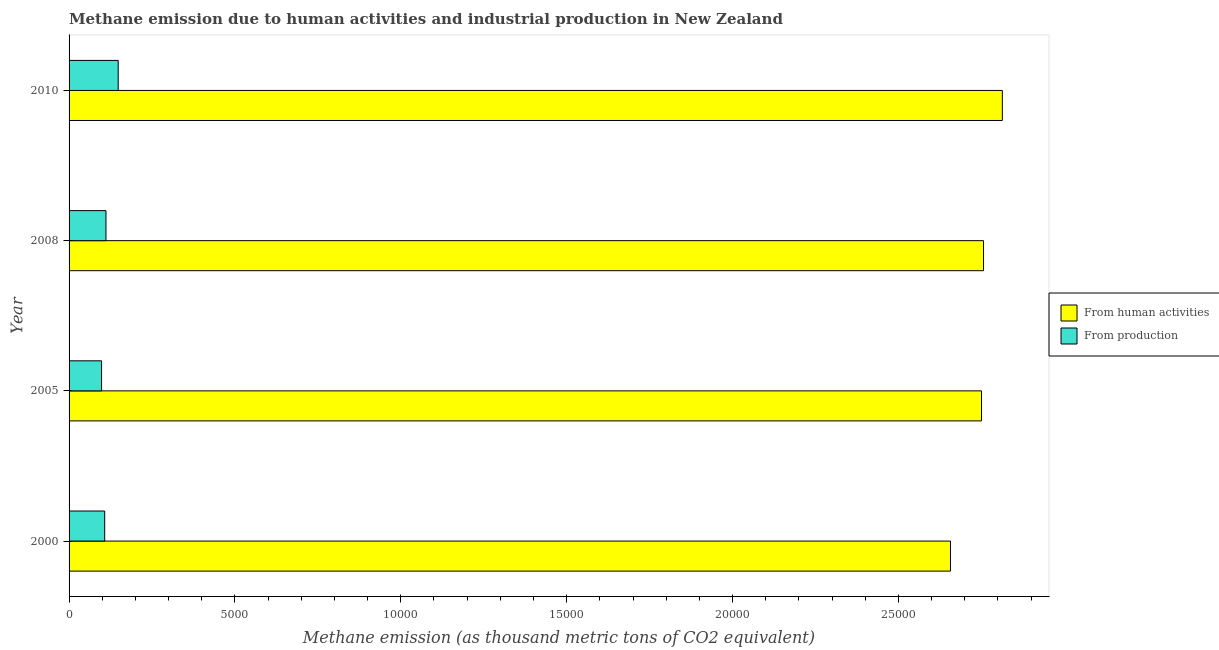How many different coloured bars are there?
Make the answer very short. 2. Are the number of bars per tick equal to the number of legend labels?
Offer a very short reply. Yes. Are the number of bars on each tick of the Y-axis equal?
Ensure brevity in your answer.  Yes. How many bars are there on the 4th tick from the bottom?
Keep it short and to the point. 2. What is the amount of emissions generated from industries in 2008?
Keep it short and to the point. 1112.6. Across all years, what is the maximum amount of emissions from human activities?
Make the answer very short. 2.81e+04. Across all years, what is the minimum amount of emissions from human activities?
Offer a very short reply. 2.66e+04. In which year was the amount of emissions generated from industries maximum?
Provide a short and direct response. 2010. In which year was the amount of emissions generated from industries minimum?
Provide a short and direct response. 2005. What is the total amount of emissions from human activities in the graph?
Give a very brief answer. 1.10e+05. What is the difference between the amount of emissions generated from industries in 2005 and that in 2008?
Give a very brief answer. -133.2. What is the difference between the amount of emissions generated from industries in 2005 and the amount of emissions from human activities in 2008?
Give a very brief answer. -2.66e+04. What is the average amount of emissions from human activities per year?
Keep it short and to the point. 2.74e+04. In the year 2005, what is the difference between the amount of emissions from human activities and amount of emissions generated from industries?
Provide a short and direct response. 2.65e+04. In how many years, is the amount of emissions generated from industries greater than 11000 thousand metric tons?
Your response must be concise. 0. What is the ratio of the amount of emissions from human activities in 2005 to that in 2010?
Ensure brevity in your answer.  0.98. Is the amount of emissions from human activities in 2000 less than that in 2008?
Your response must be concise. Yes. Is the difference between the amount of emissions from human activities in 2005 and 2010 greater than the difference between the amount of emissions generated from industries in 2005 and 2010?
Keep it short and to the point. No. What is the difference between the highest and the second highest amount of emissions generated from industries?
Offer a terse response. 368.6. What is the difference between the highest and the lowest amount of emissions generated from industries?
Your response must be concise. 501.8. What does the 2nd bar from the top in 2000 represents?
Make the answer very short. From human activities. What does the 1st bar from the bottom in 2000 represents?
Your answer should be very brief. From human activities. How many bars are there?
Make the answer very short. 8. How many years are there in the graph?
Offer a terse response. 4. Are the values on the major ticks of X-axis written in scientific E-notation?
Your answer should be very brief. No. Does the graph contain grids?
Your answer should be very brief. No. Where does the legend appear in the graph?
Your answer should be compact. Center right. What is the title of the graph?
Your answer should be compact. Methane emission due to human activities and industrial production in New Zealand. Does "Old" appear as one of the legend labels in the graph?
Offer a terse response. No. What is the label or title of the X-axis?
Provide a succinct answer. Methane emission (as thousand metric tons of CO2 equivalent). What is the label or title of the Y-axis?
Your response must be concise. Year. What is the Methane emission (as thousand metric tons of CO2 equivalent) in From human activities in 2000?
Ensure brevity in your answer.  2.66e+04. What is the Methane emission (as thousand metric tons of CO2 equivalent) in From production in 2000?
Ensure brevity in your answer.  1074. What is the Methane emission (as thousand metric tons of CO2 equivalent) of From human activities in 2005?
Give a very brief answer. 2.75e+04. What is the Methane emission (as thousand metric tons of CO2 equivalent) of From production in 2005?
Your response must be concise. 979.4. What is the Methane emission (as thousand metric tons of CO2 equivalent) of From human activities in 2008?
Offer a terse response. 2.76e+04. What is the Methane emission (as thousand metric tons of CO2 equivalent) of From production in 2008?
Keep it short and to the point. 1112.6. What is the Methane emission (as thousand metric tons of CO2 equivalent) in From human activities in 2010?
Your response must be concise. 2.81e+04. What is the Methane emission (as thousand metric tons of CO2 equivalent) of From production in 2010?
Your answer should be very brief. 1481.2. Across all years, what is the maximum Methane emission (as thousand metric tons of CO2 equivalent) of From human activities?
Give a very brief answer. 2.81e+04. Across all years, what is the maximum Methane emission (as thousand metric tons of CO2 equivalent) in From production?
Ensure brevity in your answer.  1481.2. Across all years, what is the minimum Methane emission (as thousand metric tons of CO2 equivalent) of From human activities?
Offer a very short reply. 2.66e+04. Across all years, what is the minimum Methane emission (as thousand metric tons of CO2 equivalent) of From production?
Offer a terse response. 979.4. What is the total Methane emission (as thousand metric tons of CO2 equivalent) of From human activities in the graph?
Provide a short and direct response. 1.10e+05. What is the total Methane emission (as thousand metric tons of CO2 equivalent) of From production in the graph?
Ensure brevity in your answer.  4647.2. What is the difference between the Methane emission (as thousand metric tons of CO2 equivalent) of From human activities in 2000 and that in 2005?
Your answer should be compact. -934.6. What is the difference between the Methane emission (as thousand metric tons of CO2 equivalent) in From production in 2000 and that in 2005?
Provide a short and direct response. 94.6. What is the difference between the Methane emission (as thousand metric tons of CO2 equivalent) of From human activities in 2000 and that in 2008?
Offer a terse response. -996.1. What is the difference between the Methane emission (as thousand metric tons of CO2 equivalent) of From production in 2000 and that in 2008?
Your response must be concise. -38.6. What is the difference between the Methane emission (as thousand metric tons of CO2 equivalent) in From human activities in 2000 and that in 2010?
Offer a terse response. -1563.1. What is the difference between the Methane emission (as thousand metric tons of CO2 equivalent) of From production in 2000 and that in 2010?
Keep it short and to the point. -407.2. What is the difference between the Methane emission (as thousand metric tons of CO2 equivalent) of From human activities in 2005 and that in 2008?
Provide a succinct answer. -61.5. What is the difference between the Methane emission (as thousand metric tons of CO2 equivalent) in From production in 2005 and that in 2008?
Your answer should be very brief. -133.2. What is the difference between the Methane emission (as thousand metric tons of CO2 equivalent) in From human activities in 2005 and that in 2010?
Your answer should be compact. -628.5. What is the difference between the Methane emission (as thousand metric tons of CO2 equivalent) of From production in 2005 and that in 2010?
Your answer should be compact. -501.8. What is the difference between the Methane emission (as thousand metric tons of CO2 equivalent) of From human activities in 2008 and that in 2010?
Provide a succinct answer. -567. What is the difference between the Methane emission (as thousand metric tons of CO2 equivalent) of From production in 2008 and that in 2010?
Your answer should be very brief. -368.6. What is the difference between the Methane emission (as thousand metric tons of CO2 equivalent) in From human activities in 2000 and the Methane emission (as thousand metric tons of CO2 equivalent) in From production in 2005?
Your answer should be compact. 2.56e+04. What is the difference between the Methane emission (as thousand metric tons of CO2 equivalent) of From human activities in 2000 and the Methane emission (as thousand metric tons of CO2 equivalent) of From production in 2008?
Provide a succinct answer. 2.55e+04. What is the difference between the Methane emission (as thousand metric tons of CO2 equivalent) in From human activities in 2000 and the Methane emission (as thousand metric tons of CO2 equivalent) in From production in 2010?
Your answer should be very brief. 2.51e+04. What is the difference between the Methane emission (as thousand metric tons of CO2 equivalent) of From human activities in 2005 and the Methane emission (as thousand metric tons of CO2 equivalent) of From production in 2008?
Your answer should be compact. 2.64e+04. What is the difference between the Methane emission (as thousand metric tons of CO2 equivalent) of From human activities in 2005 and the Methane emission (as thousand metric tons of CO2 equivalent) of From production in 2010?
Your answer should be very brief. 2.60e+04. What is the difference between the Methane emission (as thousand metric tons of CO2 equivalent) in From human activities in 2008 and the Methane emission (as thousand metric tons of CO2 equivalent) in From production in 2010?
Your answer should be compact. 2.61e+04. What is the average Methane emission (as thousand metric tons of CO2 equivalent) in From human activities per year?
Your answer should be compact. 2.74e+04. What is the average Methane emission (as thousand metric tons of CO2 equivalent) of From production per year?
Provide a short and direct response. 1161.8. In the year 2000, what is the difference between the Methane emission (as thousand metric tons of CO2 equivalent) of From human activities and Methane emission (as thousand metric tons of CO2 equivalent) of From production?
Offer a very short reply. 2.55e+04. In the year 2005, what is the difference between the Methane emission (as thousand metric tons of CO2 equivalent) of From human activities and Methane emission (as thousand metric tons of CO2 equivalent) of From production?
Provide a succinct answer. 2.65e+04. In the year 2008, what is the difference between the Methane emission (as thousand metric tons of CO2 equivalent) of From human activities and Methane emission (as thousand metric tons of CO2 equivalent) of From production?
Offer a terse response. 2.65e+04. In the year 2010, what is the difference between the Methane emission (as thousand metric tons of CO2 equivalent) of From human activities and Methane emission (as thousand metric tons of CO2 equivalent) of From production?
Keep it short and to the point. 2.67e+04. What is the ratio of the Methane emission (as thousand metric tons of CO2 equivalent) of From human activities in 2000 to that in 2005?
Your answer should be compact. 0.97. What is the ratio of the Methane emission (as thousand metric tons of CO2 equivalent) of From production in 2000 to that in 2005?
Ensure brevity in your answer.  1.1. What is the ratio of the Methane emission (as thousand metric tons of CO2 equivalent) in From human activities in 2000 to that in 2008?
Provide a succinct answer. 0.96. What is the ratio of the Methane emission (as thousand metric tons of CO2 equivalent) of From production in 2000 to that in 2008?
Offer a terse response. 0.97. What is the ratio of the Methane emission (as thousand metric tons of CO2 equivalent) in From production in 2000 to that in 2010?
Offer a very short reply. 0.73. What is the ratio of the Methane emission (as thousand metric tons of CO2 equivalent) in From production in 2005 to that in 2008?
Provide a short and direct response. 0.88. What is the ratio of the Methane emission (as thousand metric tons of CO2 equivalent) of From human activities in 2005 to that in 2010?
Ensure brevity in your answer.  0.98. What is the ratio of the Methane emission (as thousand metric tons of CO2 equivalent) in From production in 2005 to that in 2010?
Provide a short and direct response. 0.66. What is the ratio of the Methane emission (as thousand metric tons of CO2 equivalent) in From human activities in 2008 to that in 2010?
Offer a terse response. 0.98. What is the ratio of the Methane emission (as thousand metric tons of CO2 equivalent) of From production in 2008 to that in 2010?
Ensure brevity in your answer.  0.75. What is the difference between the highest and the second highest Methane emission (as thousand metric tons of CO2 equivalent) of From human activities?
Your response must be concise. 567. What is the difference between the highest and the second highest Methane emission (as thousand metric tons of CO2 equivalent) in From production?
Provide a succinct answer. 368.6. What is the difference between the highest and the lowest Methane emission (as thousand metric tons of CO2 equivalent) in From human activities?
Your answer should be very brief. 1563.1. What is the difference between the highest and the lowest Methane emission (as thousand metric tons of CO2 equivalent) in From production?
Offer a very short reply. 501.8. 